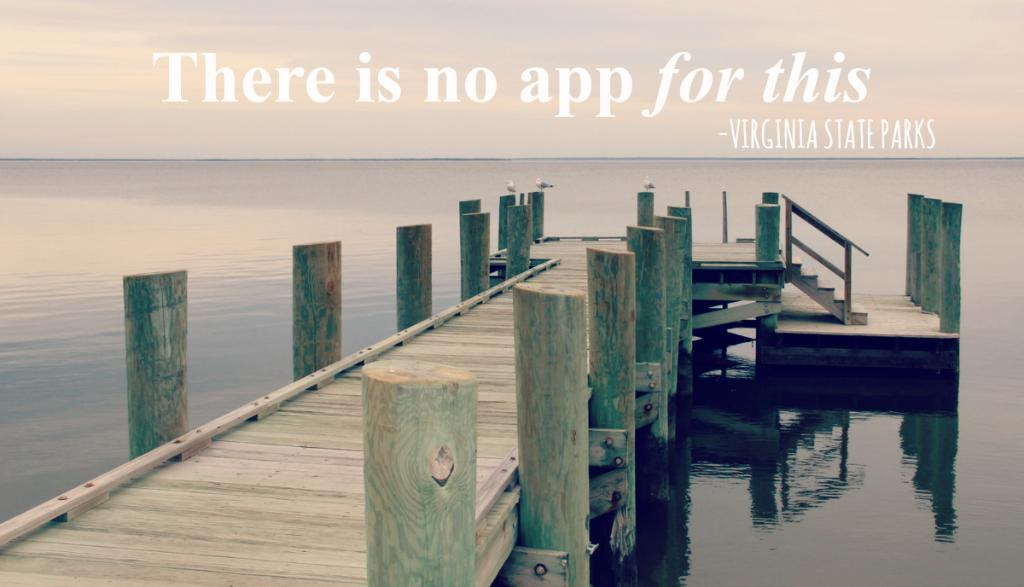What type of structure is visible in the image? There is a deck with wooden poles in the image. Are there any architectural features associated with the deck? Yes, there are steps with railing in the image. What can be seen in the background of the image? Water is visible in the image. What is written at the top of the image? There is text written at the top of the image. Can you see a cat enjoying the water in the image? There is no cat present in the image, and therefore no indication of a cat enjoying the water. What type of pleasure can be seen on the faces of the people in the image? There are no people present in the image, so it is not possible to determine their expressions or emotions. 